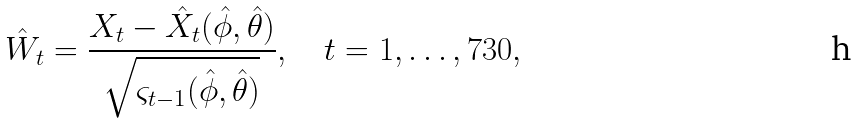<formula> <loc_0><loc_0><loc_500><loc_500>\hat { W } _ { t } = \frac { X _ { t } - \hat { X } _ { t } ( \hat { \phi } , \hat { \theta } ) } { \sqrt { \varsigma _ { t - 1 } ( \hat { \phi } , \hat { \theta } ) } } , \quad t = 1 , \dots , 7 3 0 ,</formula> 